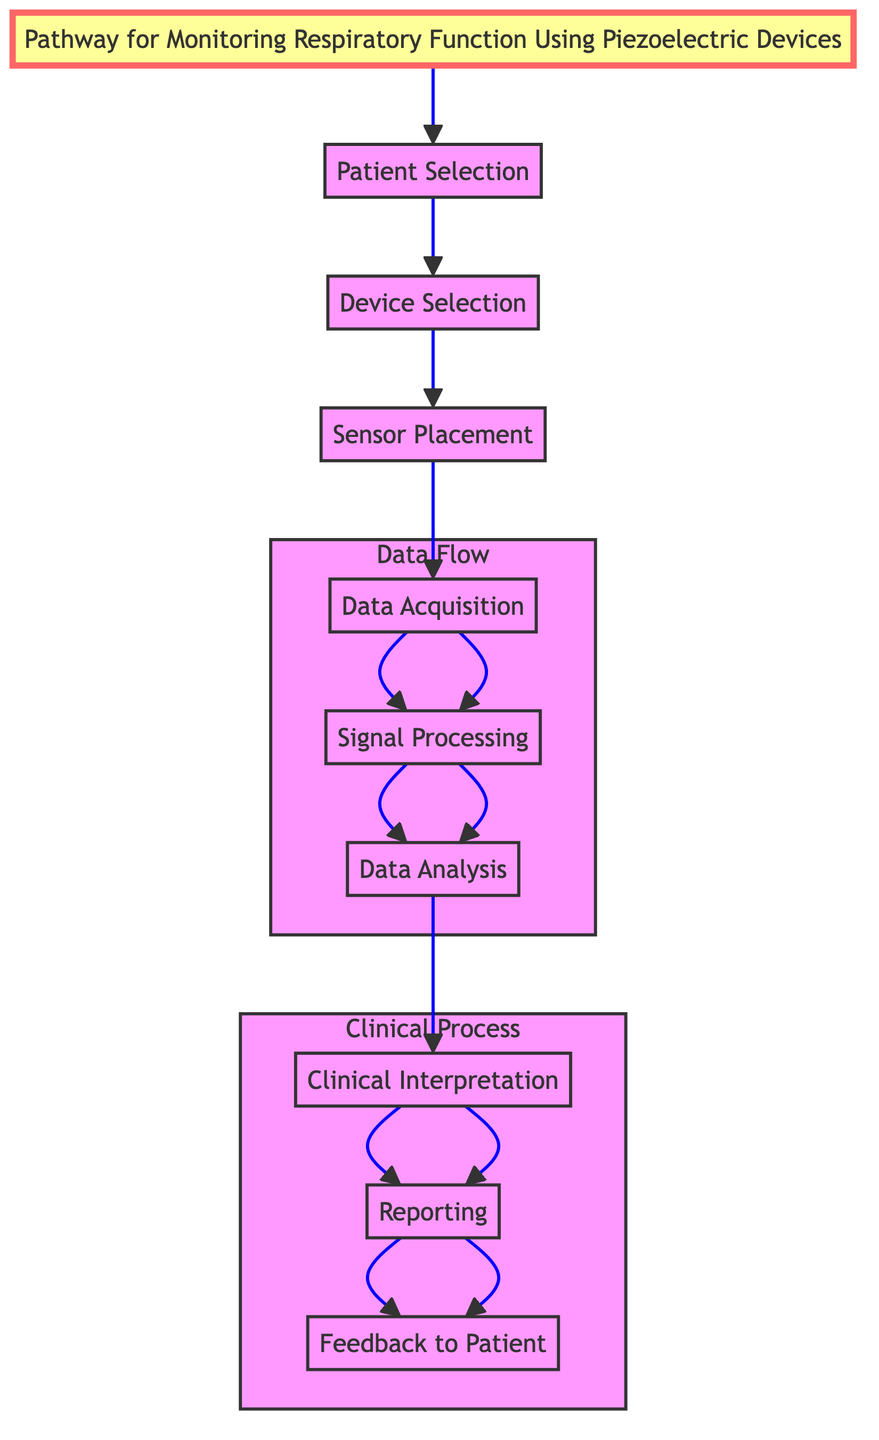What is the first step in the pathway? The first step in the pathway as indicated in the diagram is "Patient Selection." This is the initial action that starts the monitoring process for respiratory function.
Answer: Patient Selection How many steps are there in the pathway? By counting the steps listed in the diagram, there are a total of nine distinct steps involved in the clinical pathway.
Answer: Nine Which step comes after Data Acquisition? The step that follows "Data Acquisition" is "Signal Processing." The flow of the pathway clearly shows this progression from data collection to processing.
Answer: Signal Processing What type of devices are selected in the second step? The second step specifically mentions the selection of "piezoelectric devices," like PVDF-based sensors, which are suitable for detecting respiratory motion.
Answer: Piezoelectric devices What is the last step in this clinical pathway? The last step outlined in the diagram is "Feedback to Patient." This indicates the conclusion of the monitoring process, where results and recommendations are provided to the patient.
Answer: Feedback to Patient Which step involves the use of software for reporting? The step described as "Reporting" involves generating reports using software, such as MATLAB or Python, to present the findings derived from the analyzed data.
Answer: Reporting Which two steps are part of the Clinical Process subgraph? The steps that are part of the "Clinical Process" subgraph, as depicted in the diagram, are "Clinical Interpretation," "Reporting," and "Feedback to Patient." However, only the last three mentioned fall under this specific subgraph.
Answer: Clinical Interpretation, Reporting, Feedback to Patient What is the purpose of the Data Acquisition step? The "Data Acquisition" step focuses on collecting respiratory data from piezoelectric sensors through a data acquisition system like NI DAQ, serving as a crucial step in gathering necessary information.
Answer: Collect respiratory data In which section of the pathway do data processing and analysis occur? Data processing and analysis occur in the "Data Flow" section of the pathway, which includes "Data Acquisition," "Signal Processing," and "Data Analysis" as interconnected steps.
Answer: Data Flow 